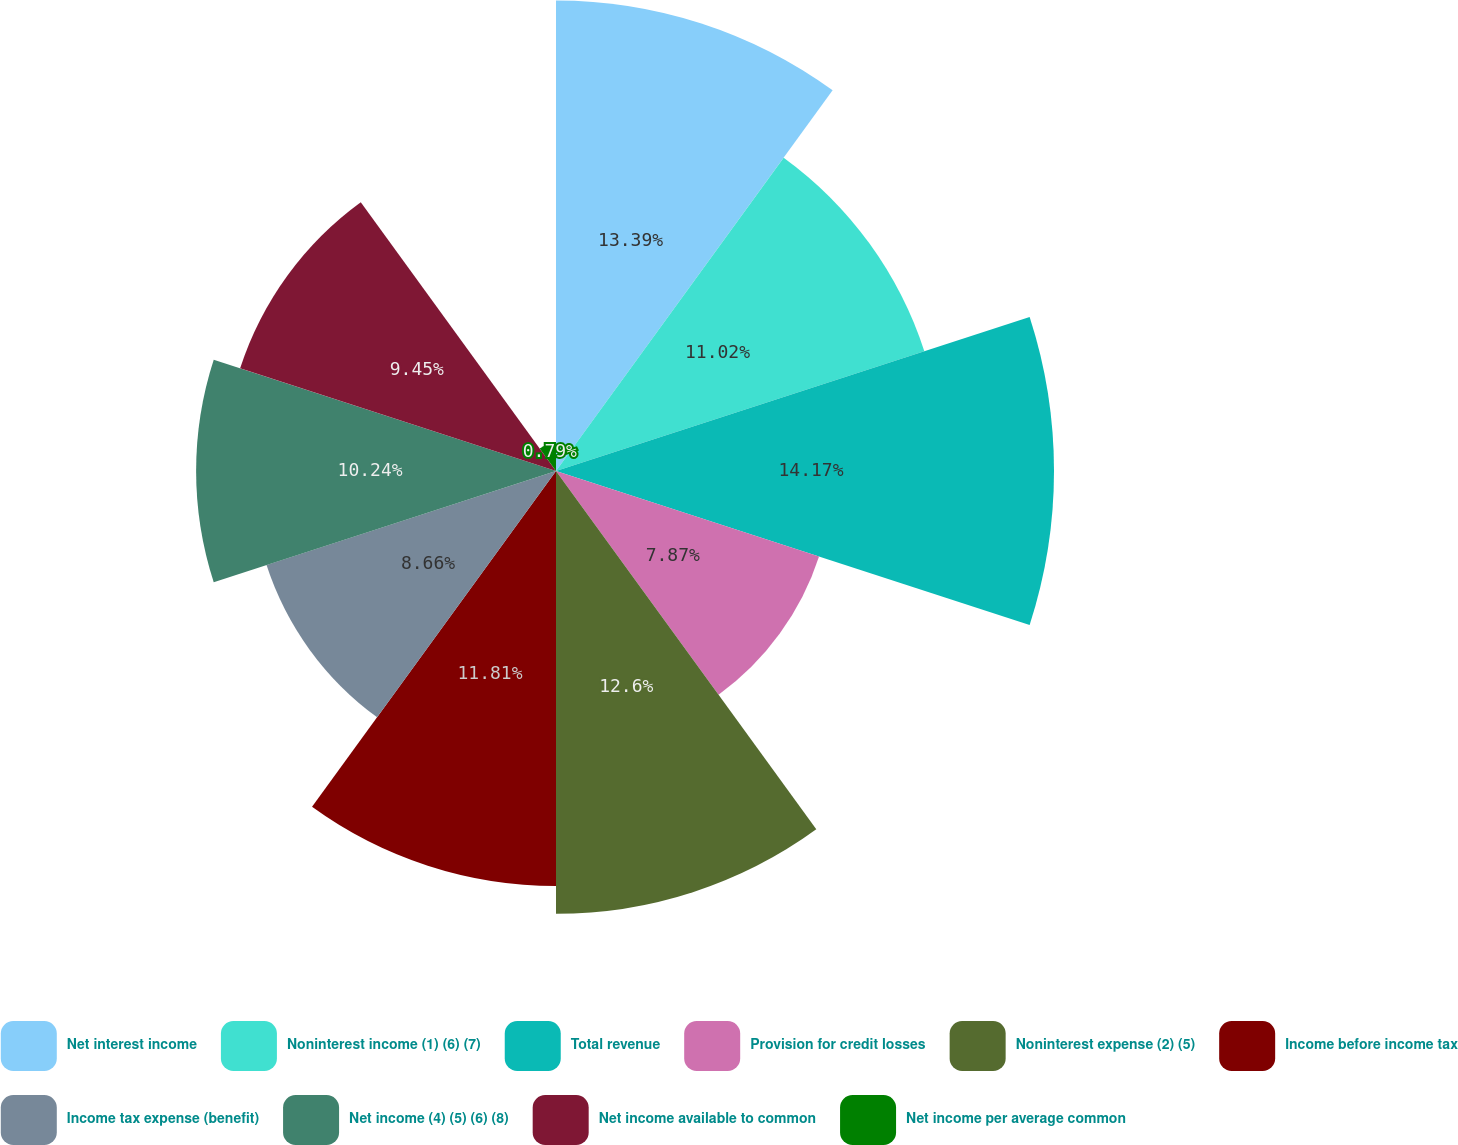Convert chart to OTSL. <chart><loc_0><loc_0><loc_500><loc_500><pie_chart><fcel>Net interest income<fcel>Noninterest income (1) (6) (7)<fcel>Total revenue<fcel>Provision for credit losses<fcel>Noninterest expense (2) (5)<fcel>Income before income tax<fcel>Income tax expense (benefit)<fcel>Net income (4) (5) (6) (8)<fcel>Net income available to common<fcel>Net income per average common<nl><fcel>13.39%<fcel>11.02%<fcel>14.17%<fcel>7.87%<fcel>12.6%<fcel>11.81%<fcel>8.66%<fcel>10.24%<fcel>9.45%<fcel>0.79%<nl></chart> 